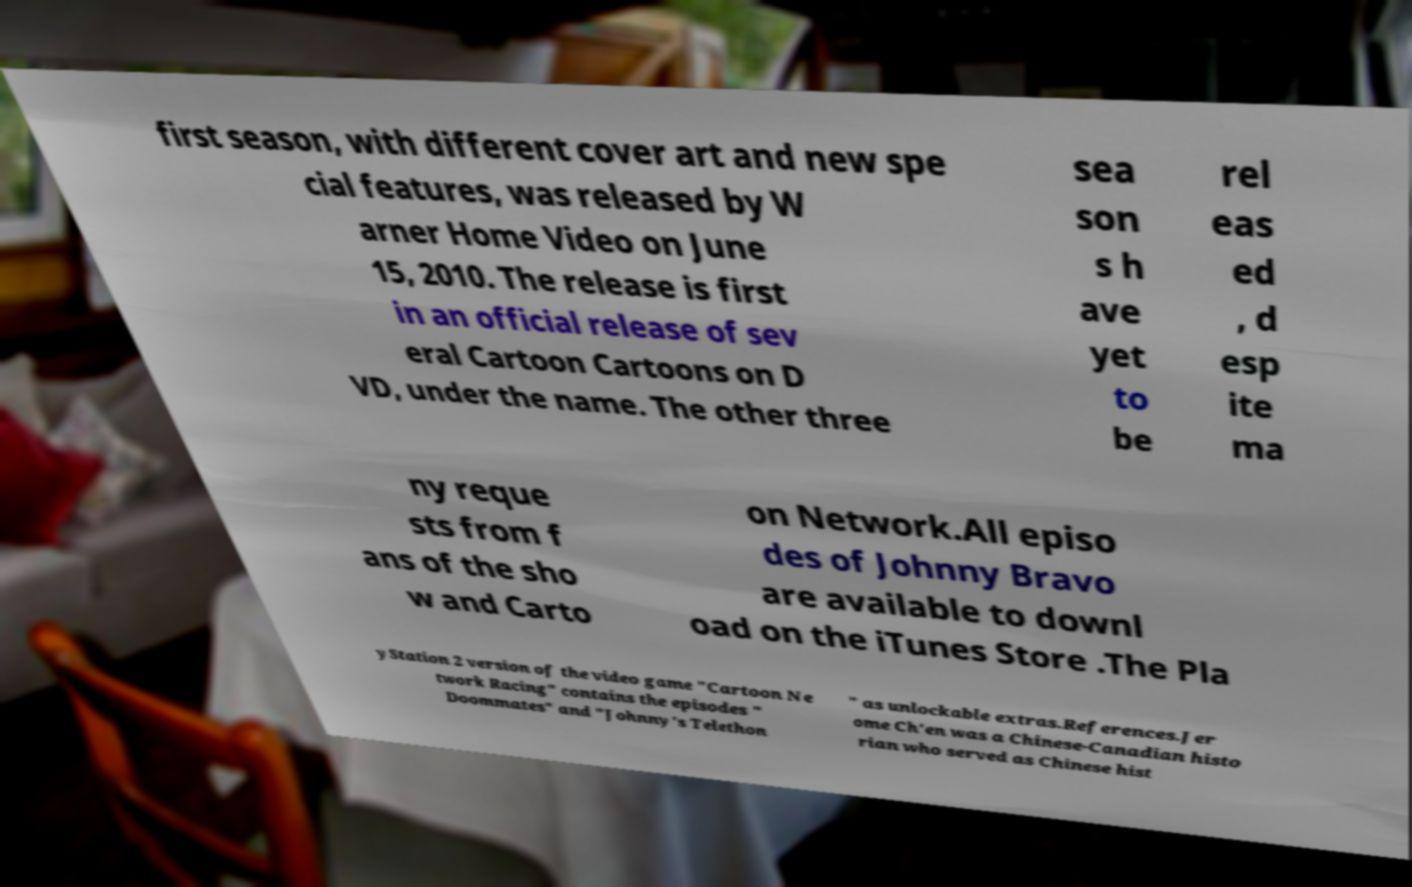Could you extract and type out the text from this image? first season, with different cover art and new spe cial features, was released by W arner Home Video on June 15, 2010. The release is first in an official release of sev eral Cartoon Cartoons on D VD, under the name. The other three sea son s h ave yet to be rel eas ed , d esp ite ma ny reque sts from f ans of the sho w and Carto on Network.All episo des of Johnny Bravo are available to downl oad on the iTunes Store .The Pla yStation 2 version of the video game "Cartoon Ne twork Racing" contains the episodes " Doommates" and "Johnny's Telethon " as unlockable extras.References.Jer ome Ch'en was a Chinese-Canadian histo rian who served as Chinese hist 